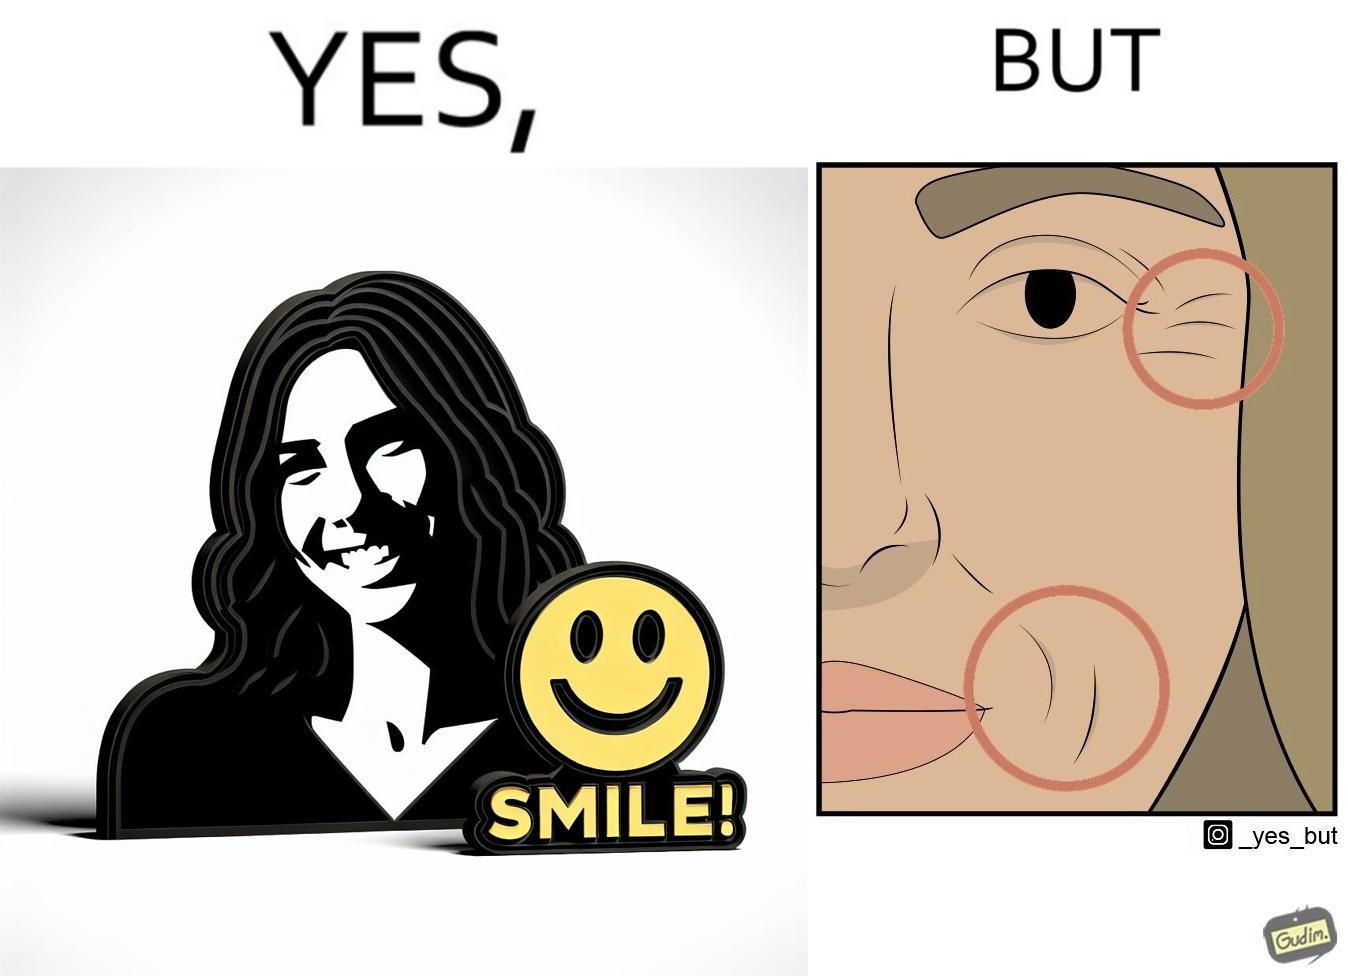Would you classify this image as satirical? Yes, this image is satirical. 